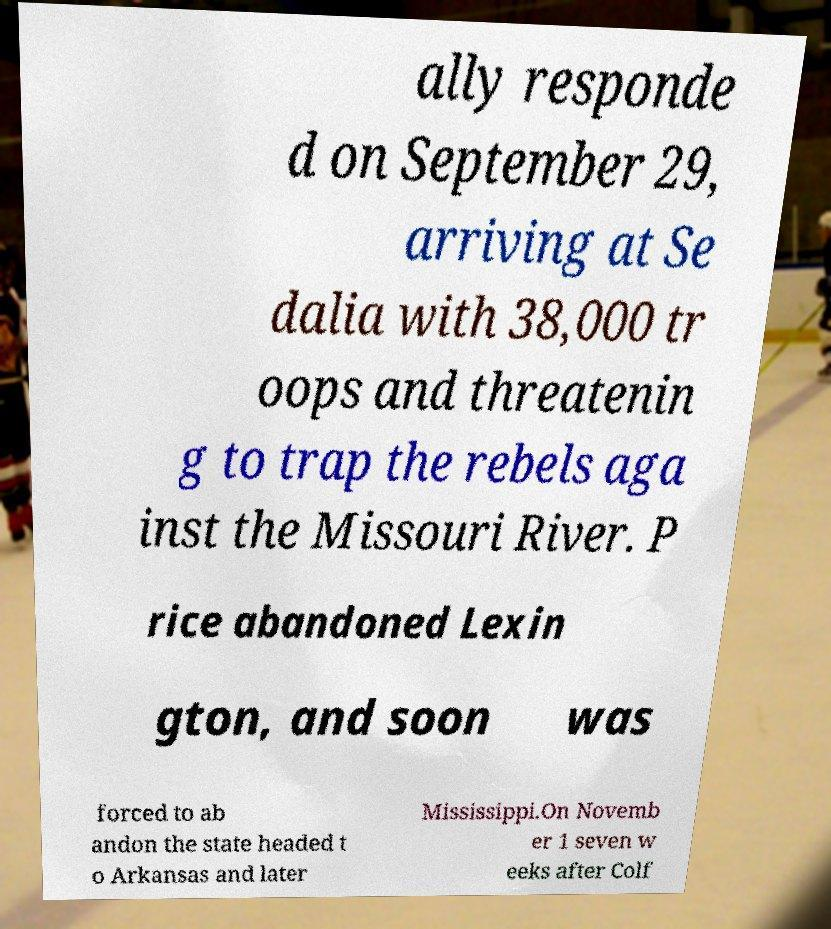Could you assist in decoding the text presented in this image and type it out clearly? ally responde d on September 29, arriving at Se dalia with 38,000 tr oops and threatenin g to trap the rebels aga inst the Missouri River. P rice abandoned Lexin gton, and soon was forced to ab andon the state headed t o Arkansas and later Mississippi.On Novemb er 1 seven w eeks after Colf 